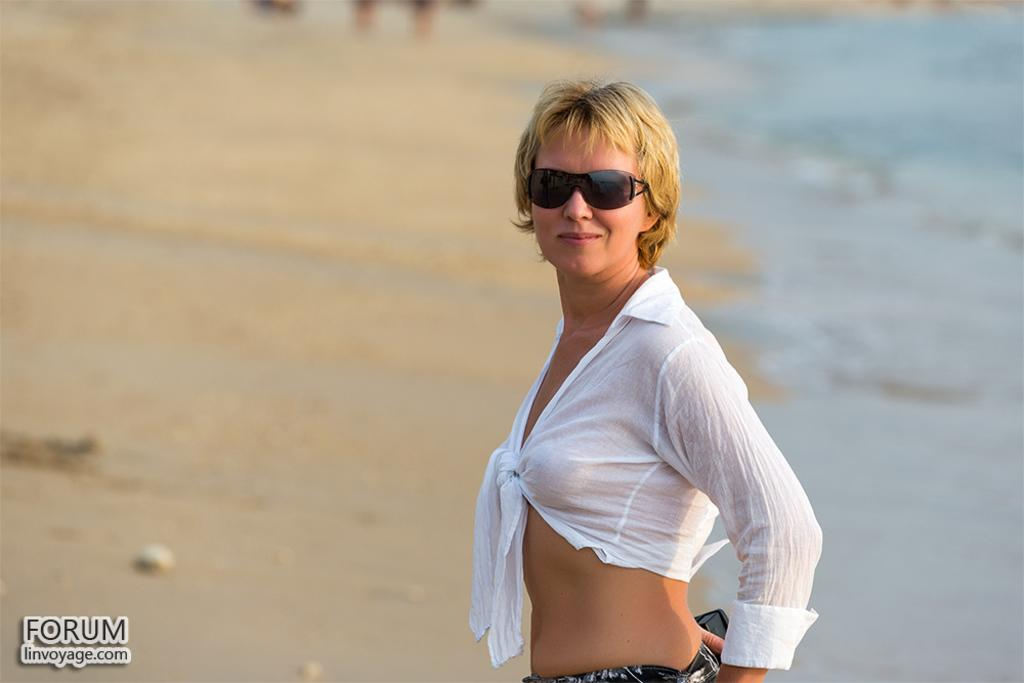Who is the main subject in the image? There is a lady in the image. What is the lady wearing in the image? The lady is wearing spectacles in the image. Can you describe the background of the image? The background of the image is blurred. Is there any text present in the image? Yes, there is some text in the bottom left corner of the image. How many babies are visible in the image? There are no babies present in the image. What type of insurance policy is being advertised in the image? There is no insurance policy being advertised in the image. 